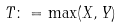<formula> <loc_0><loc_0><loc_500><loc_500>T \colon = \max ( X , Y )</formula> 